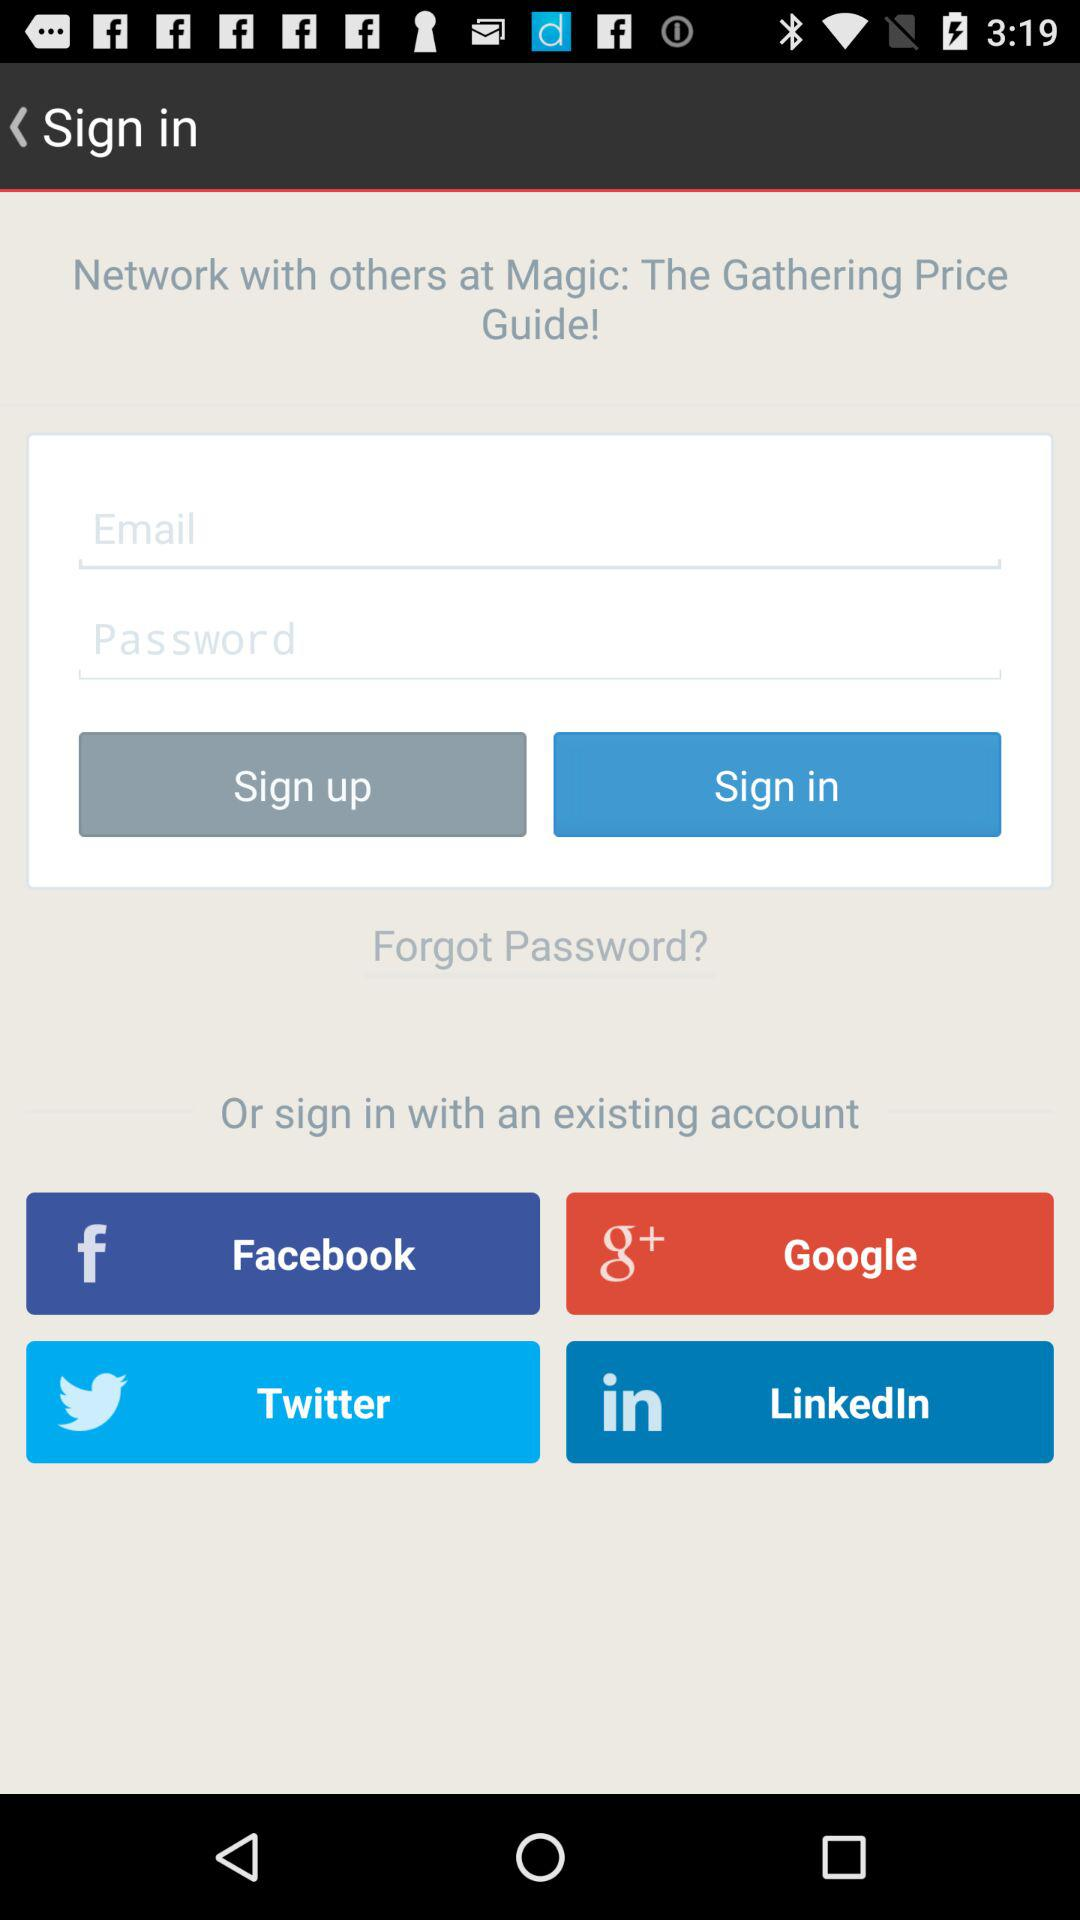Which options are given to sign in with the existing account? You can sign in with "Facebook", "Google", "Twitter" and "LinkedIn". 